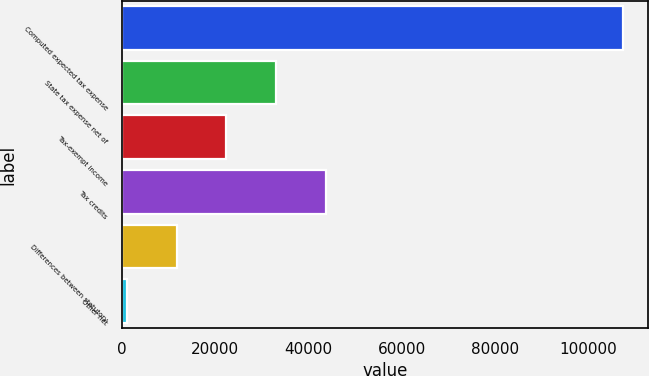Convert chart to OTSL. <chart><loc_0><loc_0><loc_500><loc_500><bar_chart><fcel>Computed expected tax expense<fcel>State tax expense net of<fcel>Tax-exempt income<fcel>Tax credits<fcel>Differences between statutory<fcel>Other net<nl><fcel>107426<fcel>33033.5<fcel>22406<fcel>43661<fcel>11778.5<fcel>1151<nl></chart> 